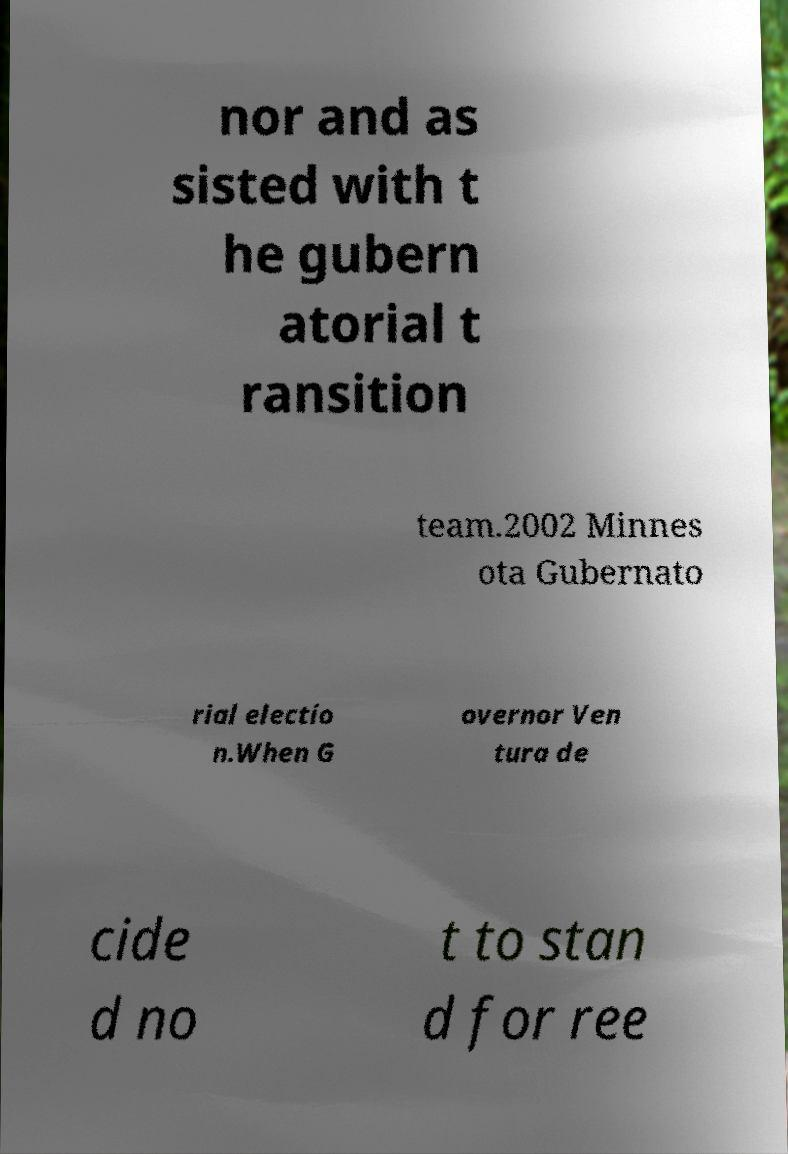What messages or text are displayed in this image? I need them in a readable, typed format. nor and as sisted with t he gubern atorial t ransition team.2002 Minnes ota Gubernato rial electio n.When G overnor Ven tura de cide d no t to stan d for ree 